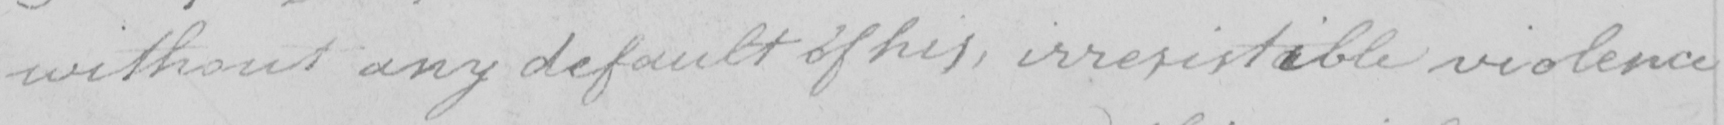Please provide the text content of this handwritten line. without any default of his , irresistaible violence 